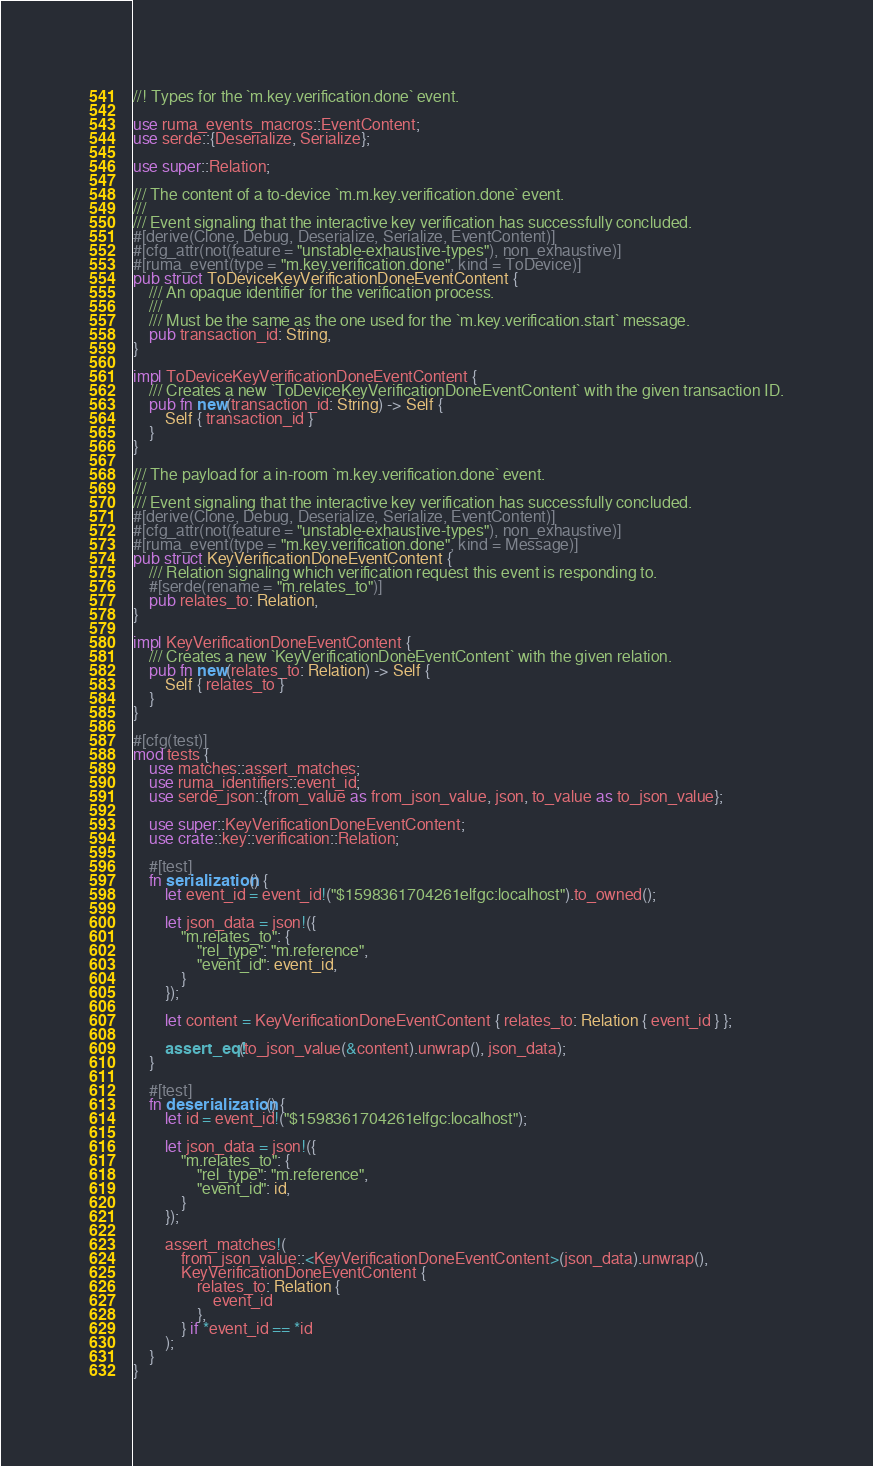Convert code to text. <code><loc_0><loc_0><loc_500><loc_500><_Rust_>//! Types for the `m.key.verification.done` event.

use ruma_events_macros::EventContent;
use serde::{Deserialize, Serialize};

use super::Relation;

/// The content of a to-device `m.m.key.verification.done` event.
///
/// Event signaling that the interactive key verification has successfully concluded.
#[derive(Clone, Debug, Deserialize, Serialize, EventContent)]
#[cfg_attr(not(feature = "unstable-exhaustive-types"), non_exhaustive)]
#[ruma_event(type = "m.key.verification.done", kind = ToDevice)]
pub struct ToDeviceKeyVerificationDoneEventContent {
    /// An opaque identifier for the verification process.
    ///
    /// Must be the same as the one used for the `m.key.verification.start` message.
    pub transaction_id: String,
}

impl ToDeviceKeyVerificationDoneEventContent {
    /// Creates a new `ToDeviceKeyVerificationDoneEventContent` with the given transaction ID.
    pub fn new(transaction_id: String) -> Self {
        Self { transaction_id }
    }
}

/// The payload for a in-room `m.key.verification.done` event.
///
/// Event signaling that the interactive key verification has successfully concluded.
#[derive(Clone, Debug, Deserialize, Serialize, EventContent)]
#[cfg_attr(not(feature = "unstable-exhaustive-types"), non_exhaustive)]
#[ruma_event(type = "m.key.verification.done", kind = Message)]
pub struct KeyVerificationDoneEventContent {
    /// Relation signaling which verification request this event is responding to.
    #[serde(rename = "m.relates_to")]
    pub relates_to: Relation,
}

impl KeyVerificationDoneEventContent {
    /// Creates a new `KeyVerificationDoneEventContent` with the given relation.
    pub fn new(relates_to: Relation) -> Self {
        Self { relates_to }
    }
}

#[cfg(test)]
mod tests {
    use matches::assert_matches;
    use ruma_identifiers::event_id;
    use serde_json::{from_value as from_json_value, json, to_value as to_json_value};

    use super::KeyVerificationDoneEventContent;
    use crate::key::verification::Relation;

    #[test]
    fn serialization() {
        let event_id = event_id!("$1598361704261elfgc:localhost").to_owned();

        let json_data = json!({
            "m.relates_to": {
                "rel_type": "m.reference",
                "event_id": event_id,
            }
        });

        let content = KeyVerificationDoneEventContent { relates_to: Relation { event_id } };

        assert_eq!(to_json_value(&content).unwrap(), json_data);
    }

    #[test]
    fn deserialization() {
        let id = event_id!("$1598361704261elfgc:localhost");

        let json_data = json!({
            "m.relates_to": {
                "rel_type": "m.reference",
                "event_id": id,
            }
        });

        assert_matches!(
            from_json_value::<KeyVerificationDoneEventContent>(json_data).unwrap(),
            KeyVerificationDoneEventContent {
                relates_to: Relation {
                    event_id
                },
            } if *event_id == *id
        );
    }
}
</code> 